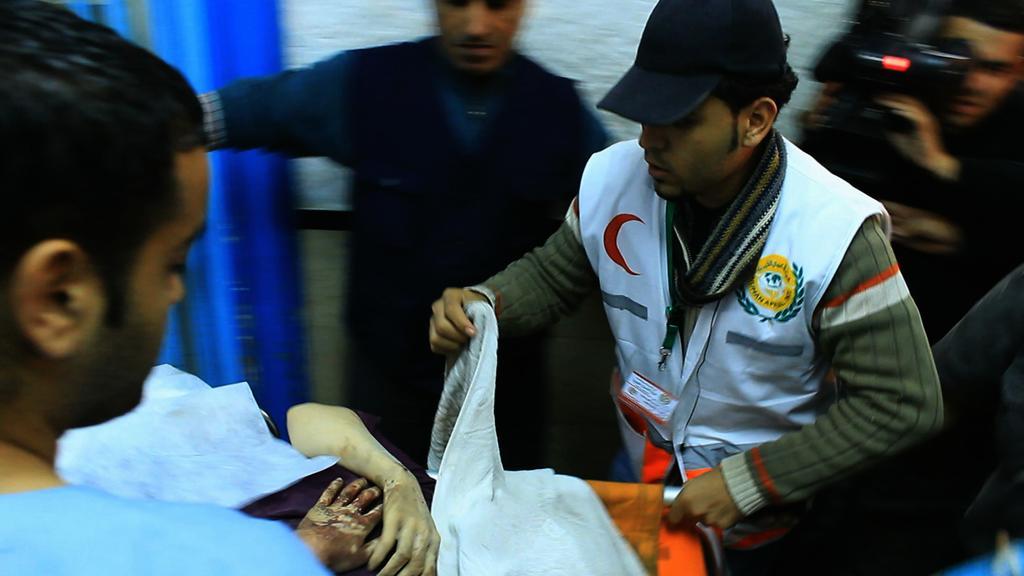How would you summarize this image in a sentence or two? On the left side, there is a person in blue color t-shirt standing near a stretcher on which there is a person laying. On the right side, there is a person holding handle of the stretcher with one hand and a cloth with other hand. In the background, there are persons, one of them is holding a camera, there is a blue color curtain and there is a white wall. 